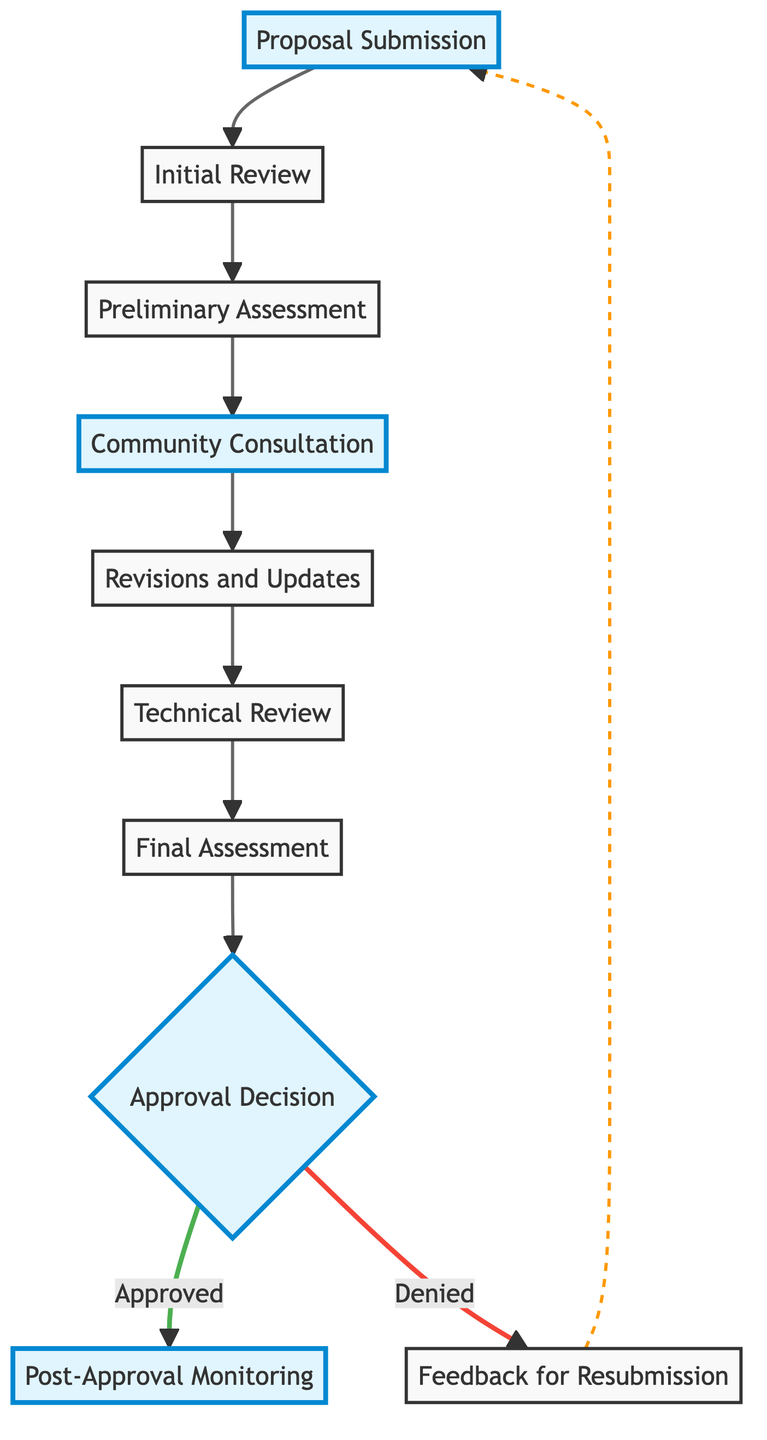What is the first step in the workflow? The first step in the workflow is labeled as "Proposal Submission," which indicates that developers begin the process by submitting their detailed project proposals.
Answer: Proposal Submission How many steps are there in total in the flowchart? By counting each distinct step shown in the flowchart, from "Proposal Submission" to "Post-Approval Monitoring," we can determine that there are nine total steps in the workflow.
Answer: Nine What follows the Community Consultation step? The flowchart shows that after the "Community Consultation" step, the next step is "Revisions and Updates," indicating that developers make changes based on the community's feedback.
Answer: Revisions and Updates What happens if the proposal is denied? According to the flowchart, if the proposal is denied, the process leads to "Feedback for Resubmission," meaning that the developers receive feedback on why their proposal was not approved.
Answer: Feedback for Resubmission How many steps lead to an approval decision? The flowchart illustrates a path leading to the "Approval Decision" step from three previous steps: "Technincal Review," "Final Assessment," and the “Preliminary Assessment." Therefore, there are three steps leading to this decision.
Answer: Three Which steps highlight community involvement? The "Community Consultation" and "Revisions and Updates" steps are specifically highlighted, indicating their importance in integrating community feedback into the proposal process.
Answer: Community Consultation, Revisions and Updates What is the outcome of the "Approval Decision" if the proposal is approved? The flowchart illustrates that if the proposal is approved, the next action is "Post-Approval Monitoring," which indicates ongoing oversight after approval.
Answer: Post-Approval Monitoring What step comes before the Technical Review? The flowchart shows that prior to the "Technical Review," the step is "Revisions and Updates," indicating that technical reviews follow the feedback-based revisions.
Answer: Revisions and Updates What type of feedback is provided if the project is denied? As indicated in the flowchart, when a proposal is denied, the outcome is "Feedback for Resubmission," which implies that constructive feedback is provided to help the developer improve the proposal for resubmission.
Answer: Feedback for Resubmission 